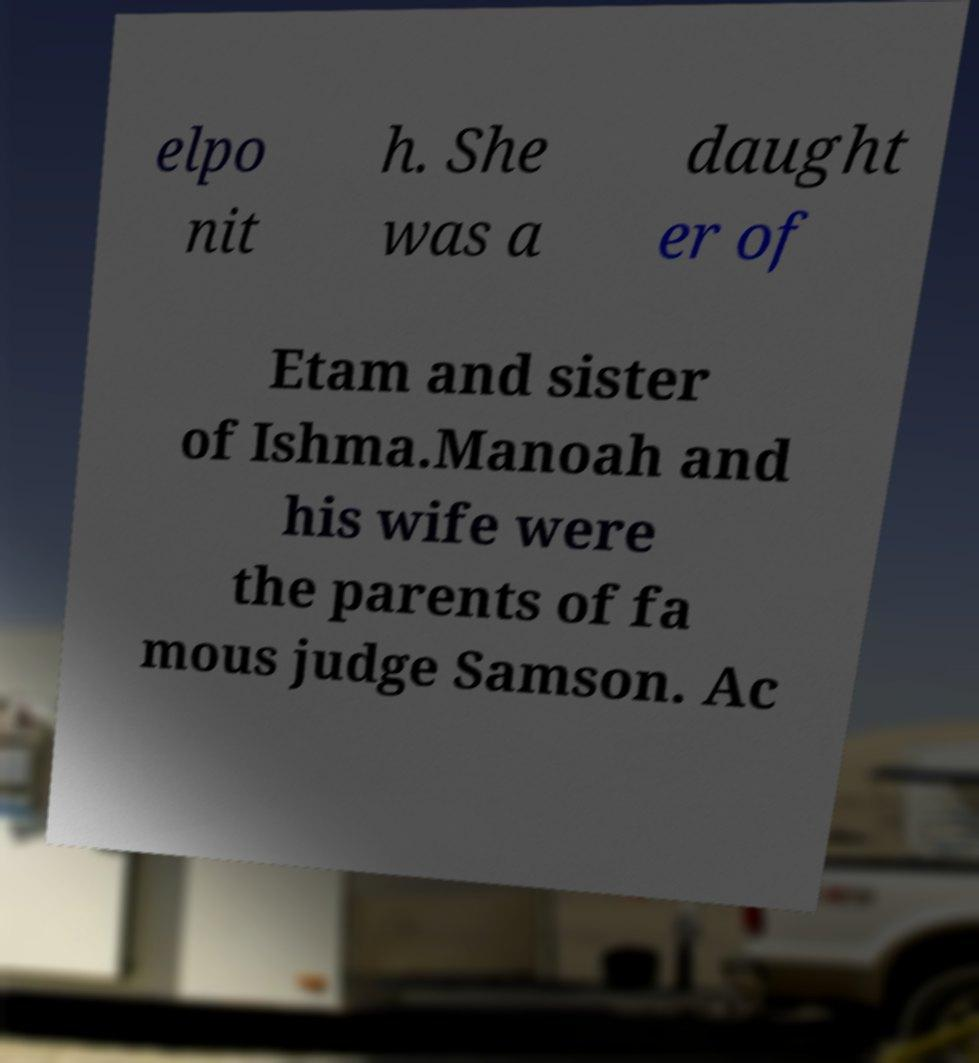Please read and relay the text visible in this image. What does it say? elpo nit h. She was a daught er of Etam and sister of Ishma.Manoah and his wife were the parents of fa mous judge Samson. Ac 